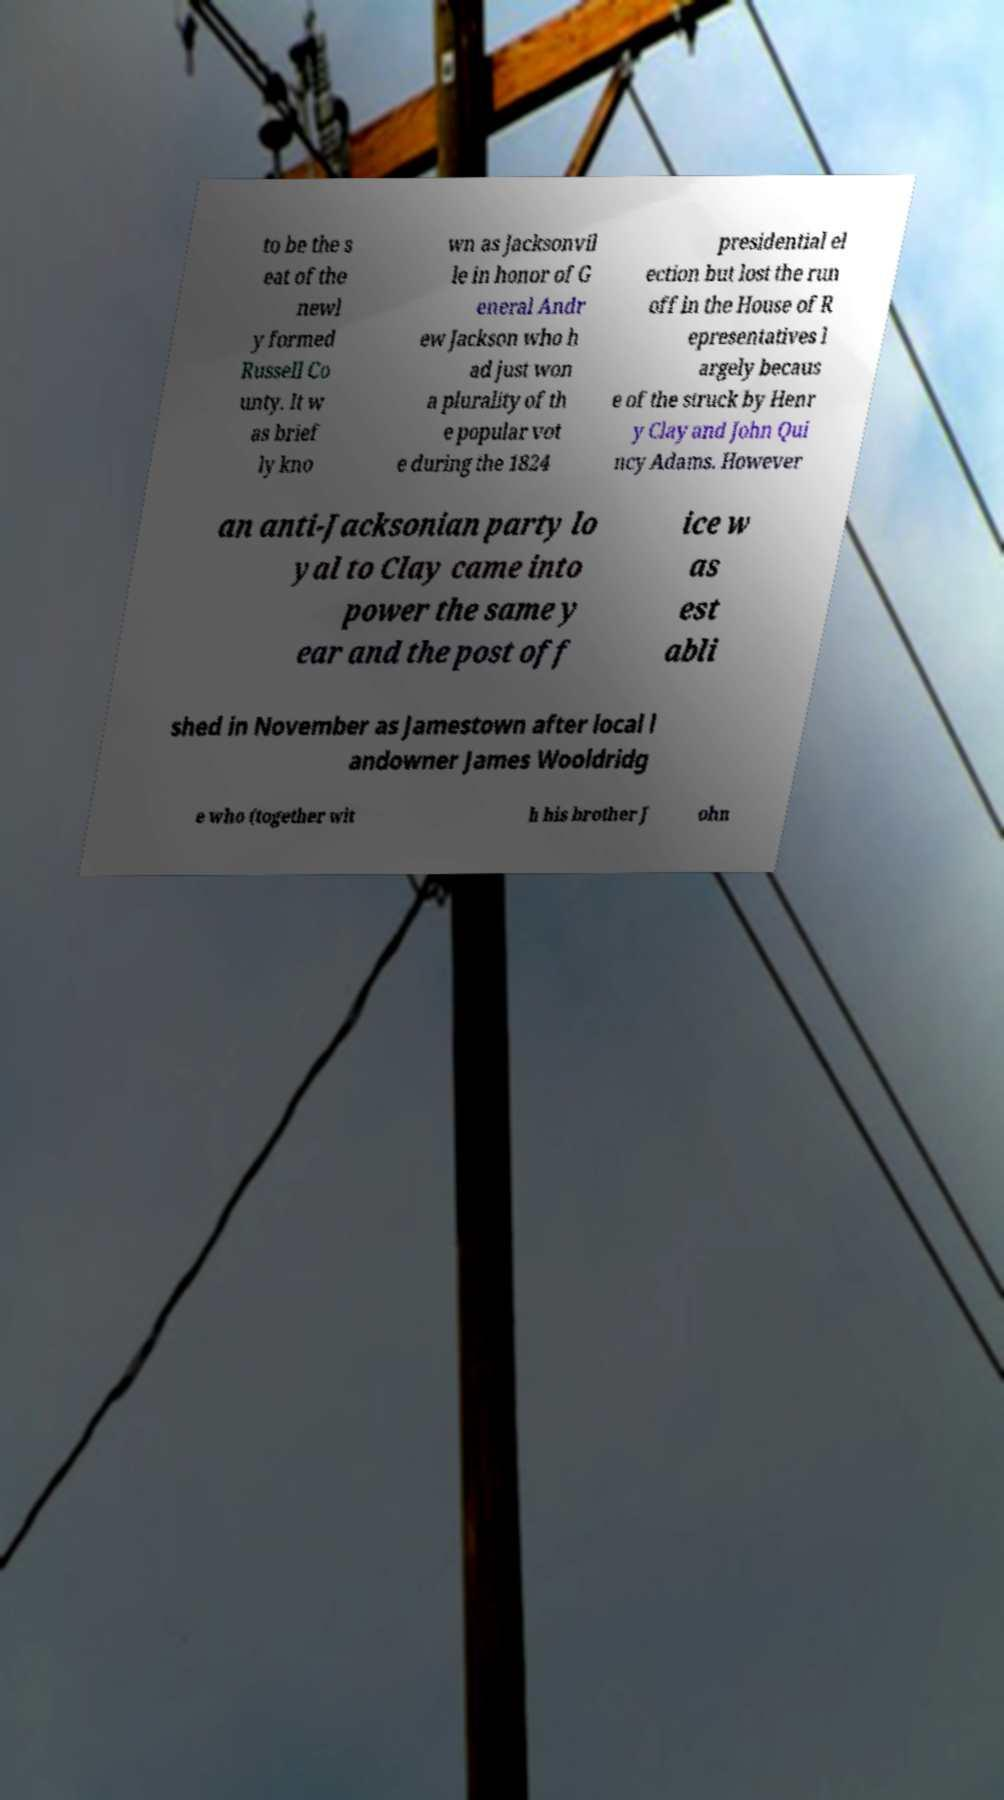Can you read and provide the text displayed in the image?This photo seems to have some interesting text. Can you extract and type it out for me? to be the s eat of the newl y formed Russell Co unty. It w as brief ly kno wn as Jacksonvil le in honor of G eneral Andr ew Jackson who h ad just won a plurality of th e popular vot e during the 1824 presidential el ection but lost the run off in the House of R epresentatives l argely becaus e of the struck by Henr y Clay and John Qui ncy Adams. However an anti-Jacksonian party lo yal to Clay came into power the same y ear and the post off ice w as est abli shed in November as Jamestown after local l andowner James Wooldridg e who (together wit h his brother J ohn 